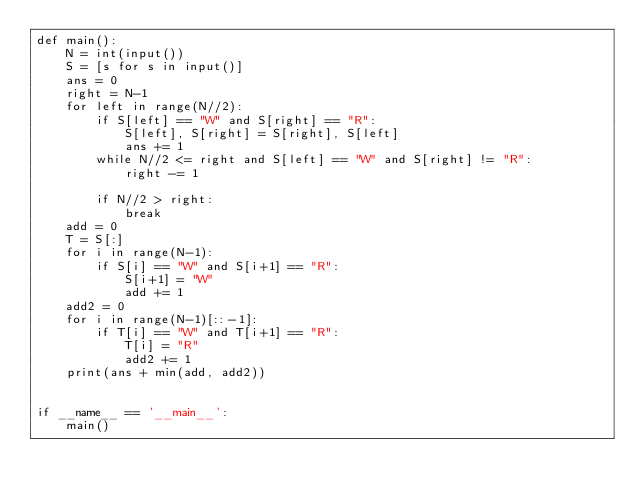Convert code to text. <code><loc_0><loc_0><loc_500><loc_500><_Python_>def main():
    N = int(input())
    S = [s for s in input()]
    ans = 0
    right = N-1
    for left in range(N//2):
        if S[left] == "W" and S[right] == "R":
            S[left], S[right] = S[right], S[left]
            ans += 1
        while N//2 <= right and S[left] == "W" and S[right] != "R":
            right -= 1

        if N//2 > right:
            break
    add = 0
    T = S[:]
    for i in range(N-1):
        if S[i] == "W" and S[i+1] == "R":
            S[i+1] = "W"
            add += 1
    add2 = 0
    for i in range(N-1)[::-1]:
        if T[i] == "W" and T[i+1] == "R":
            T[i] = "R"
            add2 += 1
    print(ans + min(add, add2))


if __name__ == '__main__':
    main()
</code> 